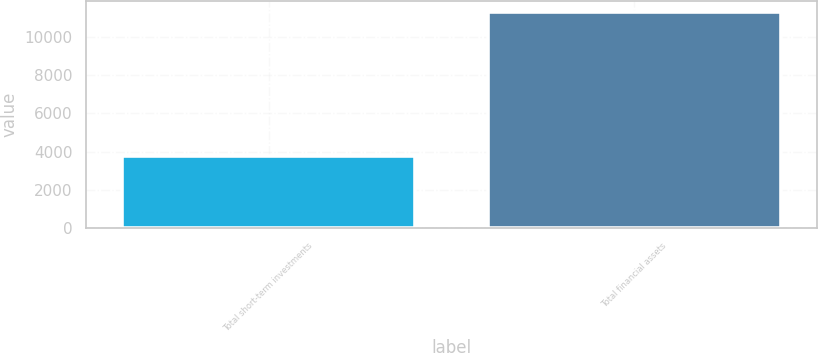Convert chart. <chart><loc_0><loc_0><loc_500><loc_500><bar_chart><fcel>Total short-term investments<fcel>Total financial assets<nl><fcel>3743<fcel>11337<nl></chart> 